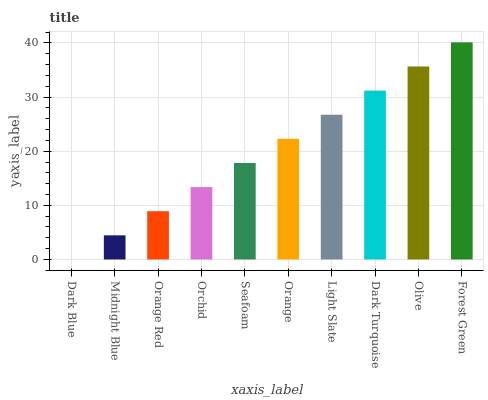Is Dark Blue the minimum?
Answer yes or no. Yes. Is Forest Green the maximum?
Answer yes or no. Yes. Is Midnight Blue the minimum?
Answer yes or no. No. Is Midnight Blue the maximum?
Answer yes or no. No. Is Midnight Blue greater than Dark Blue?
Answer yes or no. Yes. Is Dark Blue less than Midnight Blue?
Answer yes or no. Yes. Is Dark Blue greater than Midnight Blue?
Answer yes or no. No. Is Midnight Blue less than Dark Blue?
Answer yes or no. No. Is Orange the high median?
Answer yes or no. Yes. Is Seafoam the low median?
Answer yes or no. Yes. Is Orchid the high median?
Answer yes or no. No. Is Orange the low median?
Answer yes or no. No. 